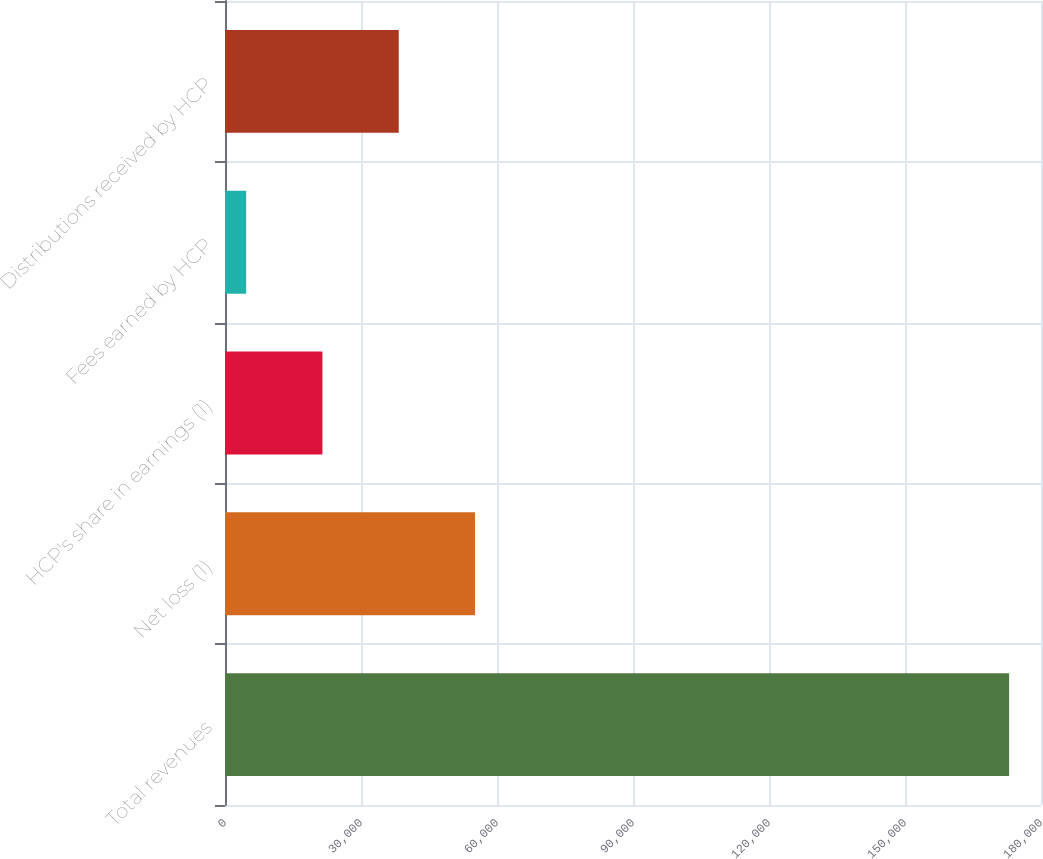<chart> <loc_0><loc_0><loc_500><loc_500><bar_chart><fcel>Total revenues<fcel>Net loss (1)<fcel>HCP's share in earnings (1)<fcel>Fees earned by HCP<fcel>Distributions received by HCP<nl><fcel>172972<fcel>55157.8<fcel>21496.6<fcel>4666<fcel>38327.2<nl></chart> 